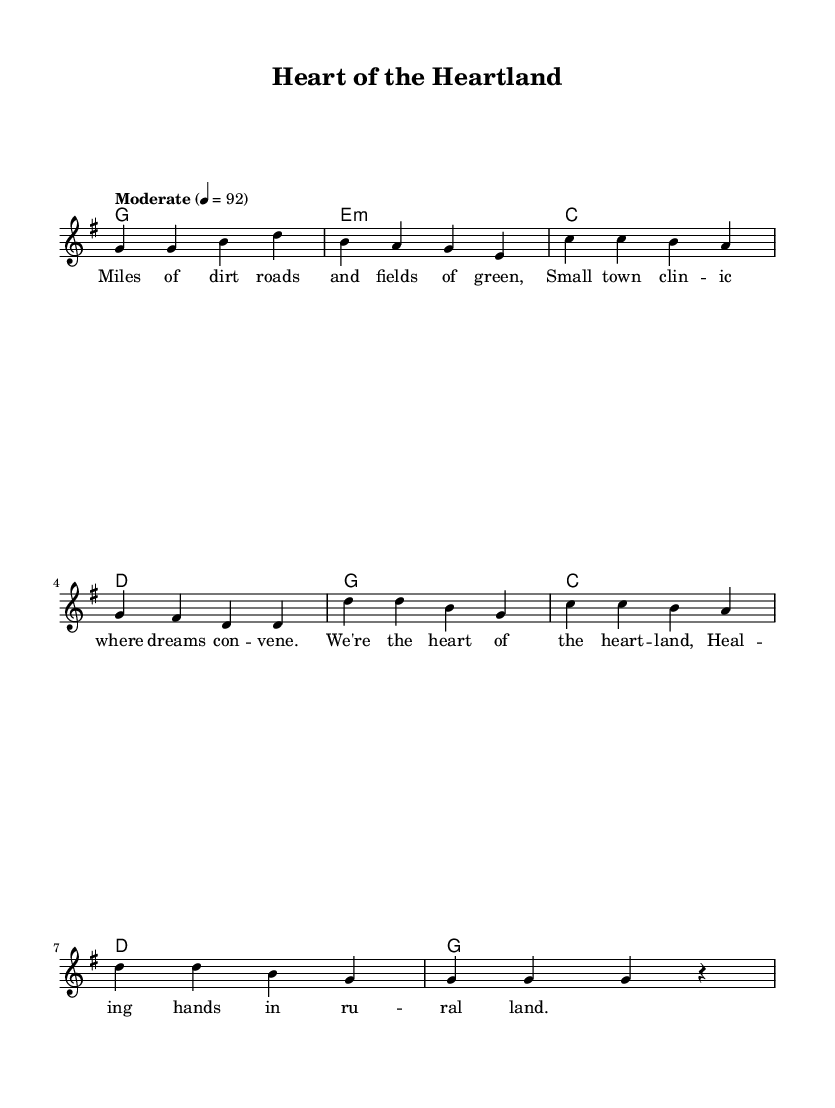What is the key signature of this music? The key signature is G major, which has one sharp (F#).
Answer: G major What is the time signature of this music? The time signature is 4/4, indicating four beats per measure.
Answer: 4/4 What is the tempo marking for this piece? The tempo marking is "Moderate" with a speed of 92 beats per minute.
Answer: Moderate 92 How many measures are in the verse? The verse consists of four measures, as indicated by the grouping of the notes in the melody and harmonies.
Answer: Four What is the rhyme scheme of the lyrics in the verse? The rhyme scheme can be identified by analyzing the end sounds of each line, which follow an AABB pattern.
Answer: AABB What are the main themes expressed in the song? The themes revolve around rural healthcare work and community support, as shown in both the lyrics and the overall feel of the music.
Answer: Rural healthcare dedication In the chorus, how many different chords are used? The chorus features three different chords: G, C, and D, which are specified in the chord progression.
Answer: Three 